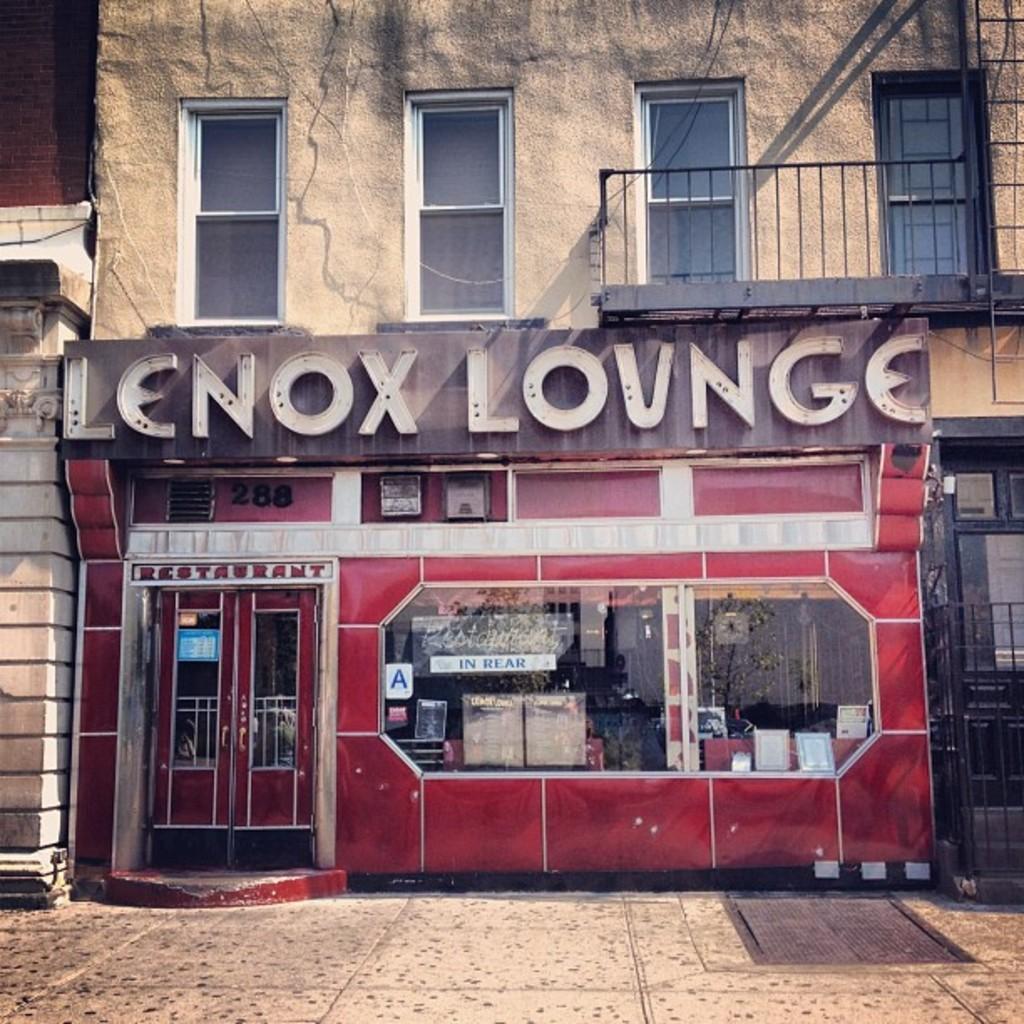Describe this image in one or two sentences. In the picture we can see a building with a shop, to it we can see doors and a glass window from it, we can see some things are placed in the shop and the top of the shop we can see a name Lennox lounge and top of it we can see some windows with glasses to it and railing and near the building we can see a path with tiles. 